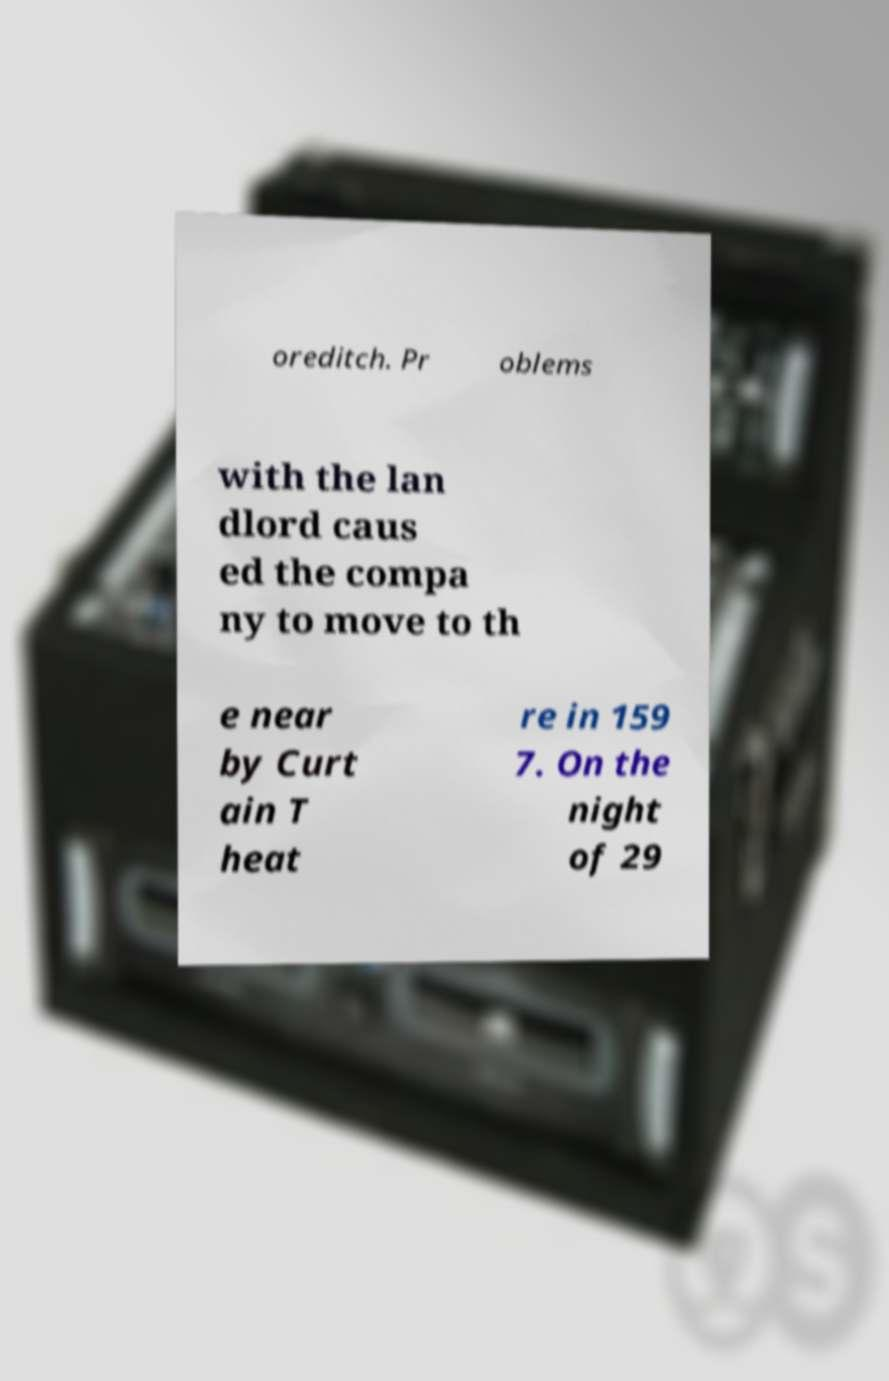For documentation purposes, I need the text within this image transcribed. Could you provide that? oreditch. Pr oblems with the lan dlord caus ed the compa ny to move to th e near by Curt ain T heat re in 159 7. On the night of 29 